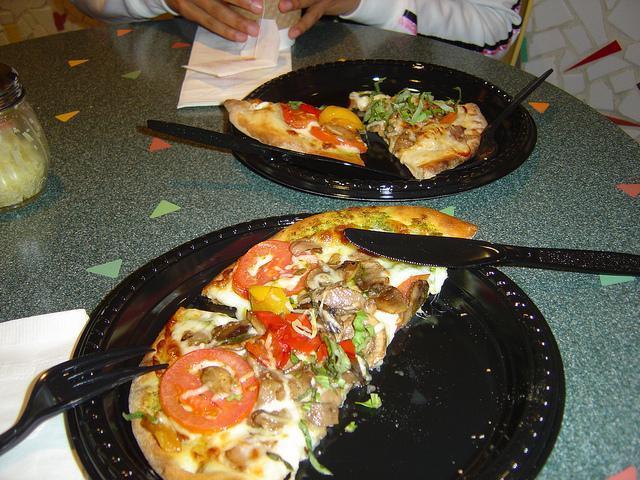How many plates are there?
Give a very brief answer. 2. How many pizzas are in the picture?
Give a very brief answer. 3. How many knives are there?
Give a very brief answer. 2. 